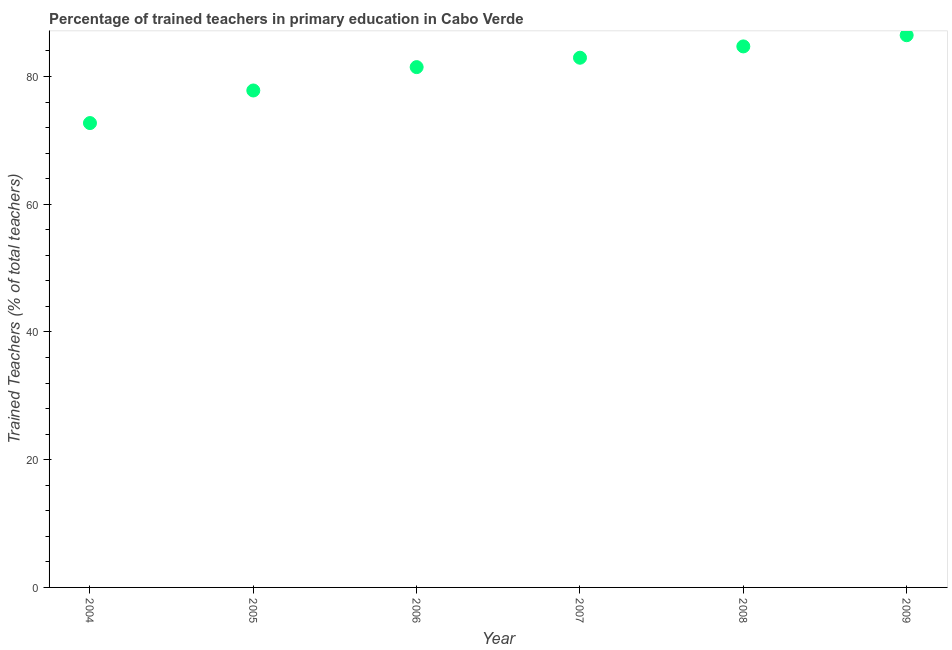What is the percentage of trained teachers in 2004?
Keep it short and to the point. 72.7. Across all years, what is the maximum percentage of trained teachers?
Your response must be concise. 86.46. Across all years, what is the minimum percentage of trained teachers?
Offer a terse response. 72.7. In which year was the percentage of trained teachers minimum?
Your answer should be compact. 2004. What is the sum of the percentage of trained teachers?
Provide a short and direct response. 486.07. What is the difference between the percentage of trained teachers in 2005 and 2006?
Your response must be concise. -3.66. What is the average percentage of trained teachers per year?
Give a very brief answer. 81.01. What is the median percentage of trained teachers?
Provide a short and direct response. 82.2. Do a majority of the years between 2007 and 2004 (inclusive) have percentage of trained teachers greater than 56 %?
Provide a succinct answer. Yes. What is the ratio of the percentage of trained teachers in 2004 to that in 2005?
Ensure brevity in your answer.  0.93. Is the percentage of trained teachers in 2007 less than that in 2009?
Give a very brief answer. Yes. What is the difference between the highest and the second highest percentage of trained teachers?
Make the answer very short. 1.75. Is the sum of the percentage of trained teachers in 2005 and 2007 greater than the maximum percentage of trained teachers across all years?
Your answer should be compact. Yes. What is the difference between the highest and the lowest percentage of trained teachers?
Your answer should be compact. 13.75. In how many years, is the percentage of trained teachers greater than the average percentage of trained teachers taken over all years?
Provide a short and direct response. 4. How many dotlines are there?
Offer a terse response. 1. Does the graph contain any zero values?
Offer a very short reply. No. What is the title of the graph?
Keep it short and to the point. Percentage of trained teachers in primary education in Cabo Verde. What is the label or title of the X-axis?
Give a very brief answer. Year. What is the label or title of the Y-axis?
Keep it short and to the point. Trained Teachers (% of total teachers). What is the Trained Teachers (% of total teachers) in 2004?
Provide a succinct answer. 72.7. What is the Trained Teachers (% of total teachers) in 2005?
Your answer should be very brief. 77.81. What is the Trained Teachers (% of total teachers) in 2006?
Your response must be concise. 81.46. What is the Trained Teachers (% of total teachers) in 2007?
Provide a succinct answer. 82.93. What is the Trained Teachers (% of total teachers) in 2008?
Your answer should be compact. 84.71. What is the Trained Teachers (% of total teachers) in 2009?
Provide a succinct answer. 86.46. What is the difference between the Trained Teachers (% of total teachers) in 2004 and 2005?
Your response must be concise. -5.1. What is the difference between the Trained Teachers (% of total teachers) in 2004 and 2006?
Provide a succinct answer. -8.76. What is the difference between the Trained Teachers (% of total teachers) in 2004 and 2007?
Your answer should be compact. -10.23. What is the difference between the Trained Teachers (% of total teachers) in 2004 and 2008?
Make the answer very short. -12. What is the difference between the Trained Teachers (% of total teachers) in 2004 and 2009?
Keep it short and to the point. -13.75. What is the difference between the Trained Teachers (% of total teachers) in 2005 and 2006?
Ensure brevity in your answer.  -3.66. What is the difference between the Trained Teachers (% of total teachers) in 2005 and 2007?
Provide a short and direct response. -5.13. What is the difference between the Trained Teachers (% of total teachers) in 2005 and 2008?
Provide a short and direct response. -6.9. What is the difference between the Trained Teachers (% of total teachers) in 2005 and 2009?
Your response must be concise. -8.65. What is the difference between the Trained Teachers (% of total teachers) in 2006 and 2007?
Provide a short and direct response. -1.47. What is the difference between the Trained Teachers (% of total teachers) in 2006 and 2008?
Your answer should be very brief. -3.24. What is the difference between the Trained Teachers (% of total teachers) in 2006 and 2009?
Offer a terse response. -4.99. What is the difference between the Trained Teachers (% of total teachers) in 2007 and 2008?
Make the answer very short. -1.77. What is the difference between the Trained Teachers (% of total teachers) in 2007 and 2009?
Provide a short and direct response. -3.52. What is the difference between the Trained Teachers (% of total teachers) in 2008 and 2009?
Keep it short and to the point. -1.75. What is the ratio of the Trained Teachers (% of total teachers) in 2004 to that in 2005?
Make the answer very short. 0.93. What is the ratio of the Trained Teachers (% of total teachers) in 2004 to that in 2006?
Provide a short and direct response. 0.89. What is the ratio of the Trained Teachers (% of total teachers) in 2004 to that in 2007?
Provide a short and direct response. 0.88. What is the ratio of the Trained Teachers (% of total teachers) in 2004 to that in 2008?
Give a very brief answer. 0.86. What is the ratio of the Trained Teachers (% of total teachers) in 2004 to that in 2009?
Ensure brevity in your answer.  0.84. What is the ratio of the Trained Teachers (% of total teachers) in 2005 to that in 2006?
Offer a very short reply. 0.95. What is the ratio of the Trained Teachers (% of total teachers) in 2005 to that in 2007?
Ensure brevity in your answer.  0.94. What is the ratio of the Trained Teachers (% of total teachers) in 2005 to that in 2008?
Give a very brief answer. 0.92. What is the ratio of the Trained Teachers (% of total teachers) in 2005 to that in 2009?
Provide a succinct answer. 0.9. What is the ratio of the Trained Teachers (% of total teachers) in 2006 to that in 2007?
Your answer should be compact. 0.98. What is the ratio of the Trained Teachers (% of total teachers) in 2006 to that in 2008?
Offer a very short reply. 0.96. What is the ratio of the Trained Teachers (% of total teachers) in 2006 to that in 2009?
Your response must be concise. 0.94. What is the ratio of the Trained Teachers (% of total teachers) in 2008 to that in 2009?
Make the answer very short. 0.98. 